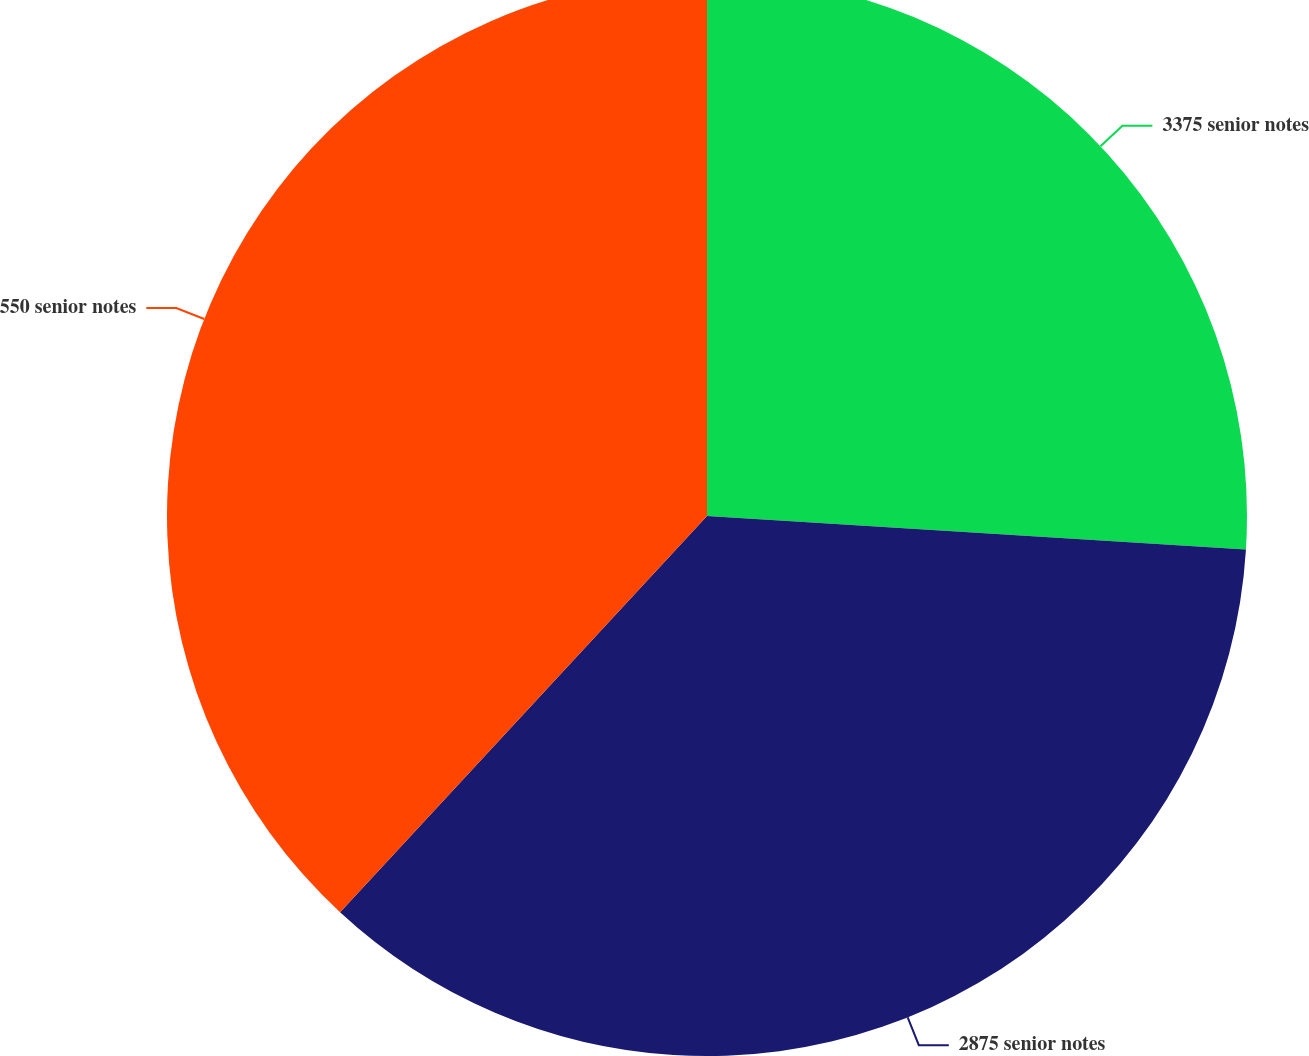<chart> <loc_0><loc_0><loc_500><loc_500><pie_chart><fcel>3375 senior notes<fcel>2875 senior notes<fcel>550 senior notes<nl><fcel>25.99%<fcel>35.9%<fcel>38.11%<nl></chart> 